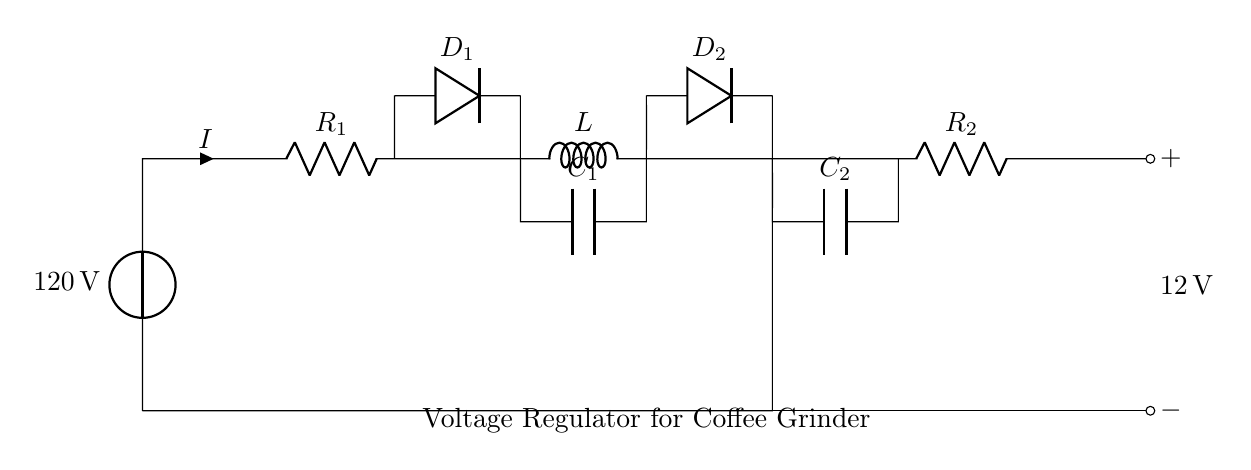What is the input voltage of this circuit? The input voltage is labeled as 120 volts, which is indicated on the voltage source component in the diagram.
Answer: 120 volts What are the passive components in the circuit? The passive components include resistors, inductors, and capacitors, which are represented in the circuit with their respective symbols (R, L, C).
Answer: Resistors, inductors, capacitors What is the purpose of the diodes in this circuit? The diodes function as one-way valves for current, allowing it to flow in one direction while blocking it in the opposite direction. This is crucial for converting alternating current to direct current in the voltage regulator setup.
Answer: Current control What is the output voltage in this circuit? The output voltage is shown as 12 volts, indicated by the voltage level noted at the output terminals in the circuit.
Answer: 12 volts How many resistors are present in this circuit? There are two resistors in the circuit labeled as R1 and R2. Each of them is represented in the schematic diagram with their respective identifiers.
Answer: Two What role does the inductor play in this circuit? The inductor, represented by L in the circuit, helps smooth out the current flow by storing energy in a magnetic field when current passes through it, which is important for stabilizing voltage levels.
Answer: Energy storage What is the configuration type of this circuit? The configuration is a voltage regulator circuit designed specifically for a coffee grinder, aimed at maintaining a stable output voltage despite varying input conditions.
Answer: Voltage regulator circuit 